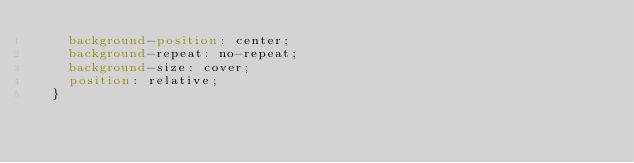<code> <loc_0><loc_0><loc_500><loc_500><_CSS_>    background-position: center;
    background-repeat: no-repeat;
    background-size: cover;
    position: relative;
  }
</code> 